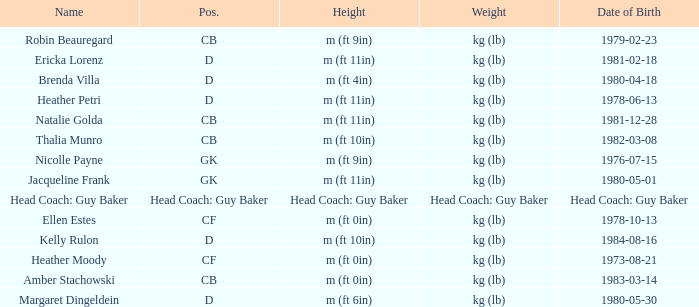Born on 1983-03-14, what is the cb's name? Amber Stachowski. 